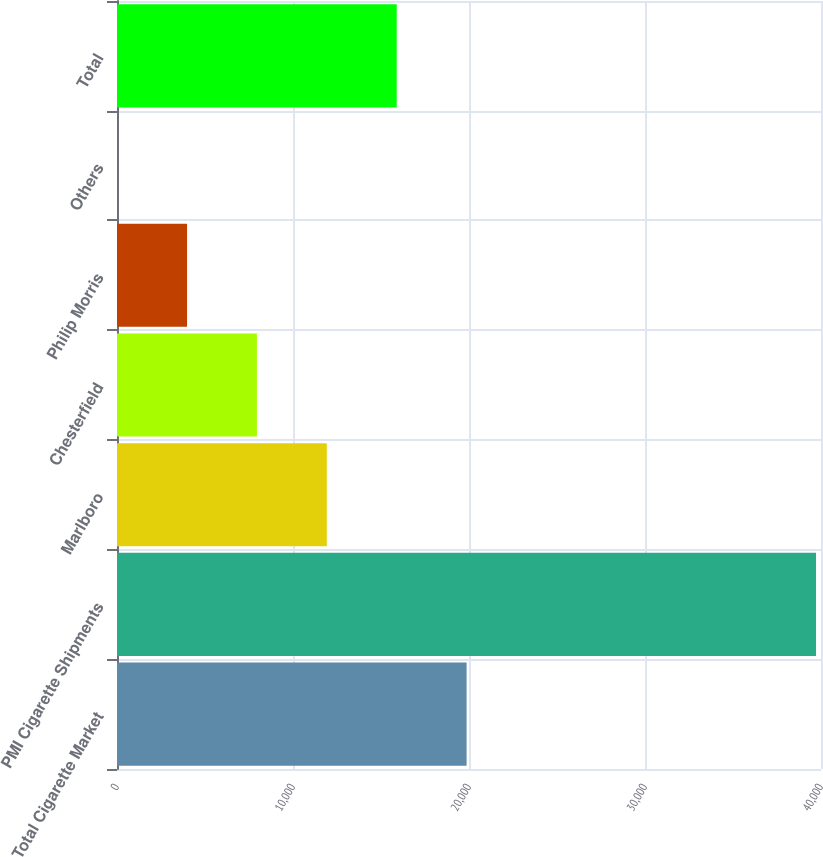<chart> <loc_0><loc_0><loc_500><loc_500><bar_chart><fcel>Total Cigarette Market<fcel>PMI Cigarette Shipments<fcel>Marlboro<fcel>Chesterfield<fcel>Philip Morris<fcel>Others<fcel>Total<nl><fcel>19862.9<fcel>39717<fcel>11921.3<fcel>7950.44<fcel>3979.62<fcel>8.8<fcel>15892.1<nl></chart> 